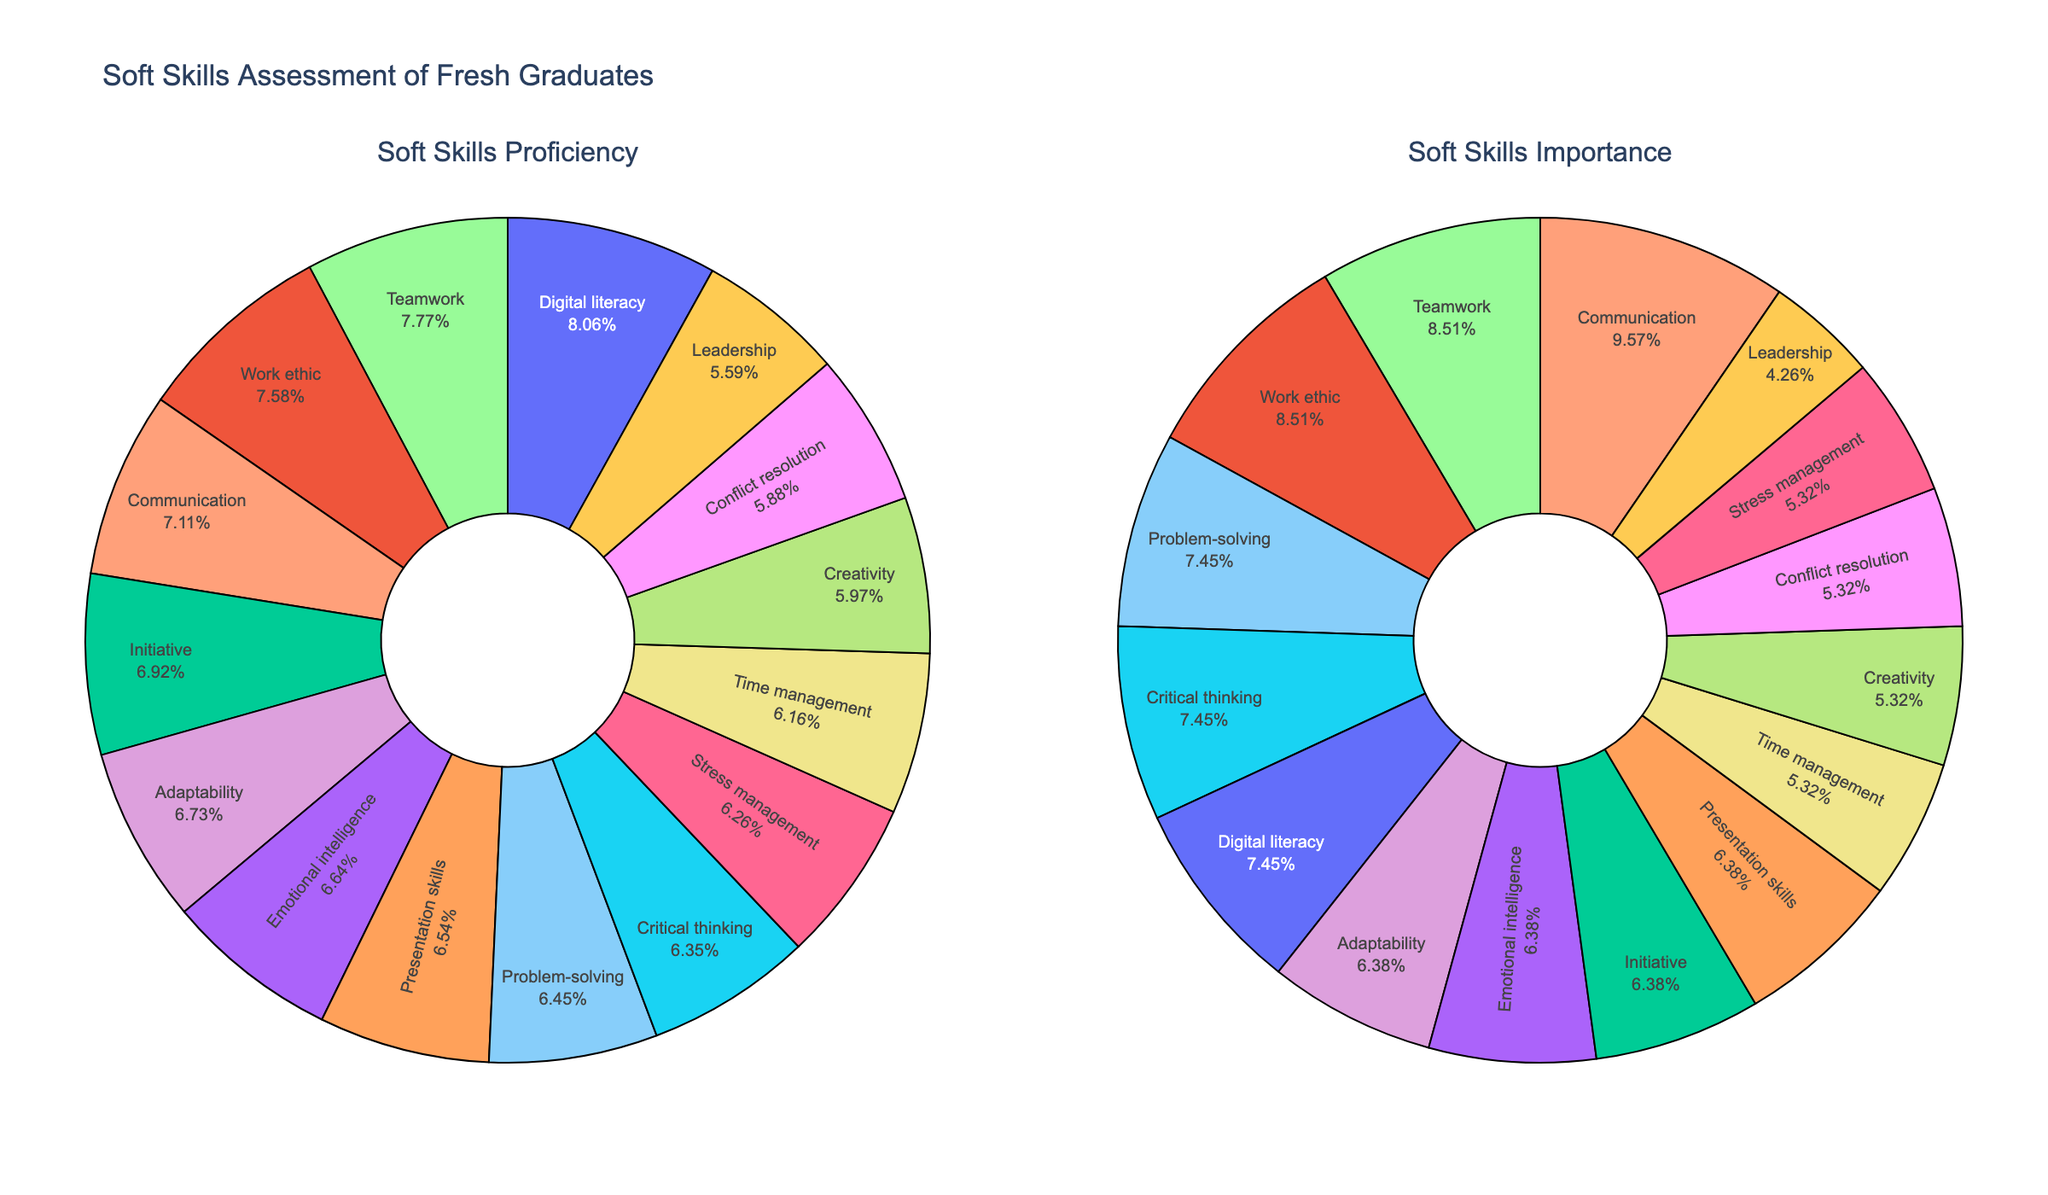How are the soft skills divided in the figure? The soft skills are divided into two pie charts: one representing proficiency and the other representing importance.
Answer: Two pie charts What's the skill with the highest proficiency percentage? By looking at the pie chart on the left, check which skill segment has the largest proportion.
Answer: Digital literacy What's the skill with the highest importance percentage? Examine the pie chart on the right to determine which skill segment appears the largest.
Answer: Communication Which skill reflects better proficiency than importance? Compare the segments for each skill in both pie charts and see which skill has a larger segment in the proficiency chart than in the importance chart.
Answer: Digital literacy How does teamwork compare in terms of proficiency and importance? Locate the teamwork segment in both charts and compare their proportions. Teamwork appears larger in the proficiency chart than in the importance chart.
Answer: Higher proficiency than importance Which skill appears equally important and proficient? Find a skill where the segments are similar in both pie charts by comparing sizes.
Answer: Work ethic Identify the skill with the lowest proficiency. From the left pie chart, determine the smallest segment representing skill proficiency.
Answer: Leadership For adaptability, how does its importance compare with proficiency? Compare the adaptability segments in both pie charts. The segment in the proficiency chart should be checked against the importance chart.
Answer: Proficiency is higher than importance What percentage does creativity hold in the proficiency chart? Look at the left pie chart and see the percentage labeled for the creativity segment.
Answer: This would typically require reading off the label directly from the chart Which skill has higher importance compared to its proficiency? Compare the proportions of each skill in the two pie charts to find which has a smaller segment in the proficiency chart but a larger segment in the importance chart.
Answer: Communication 